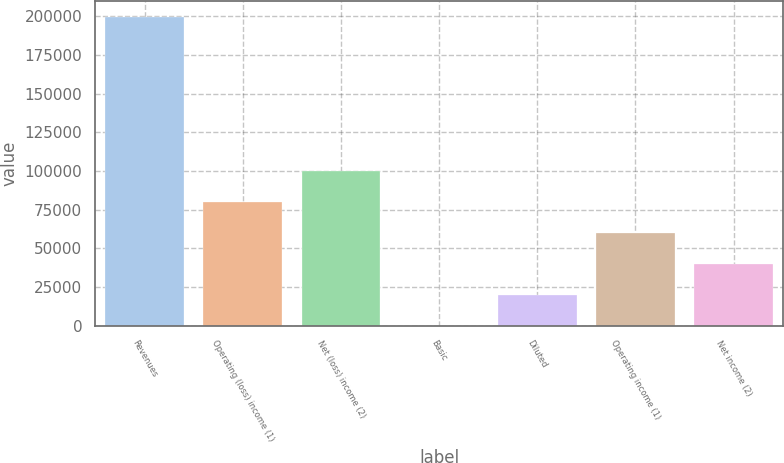<chart> <loc_0><loc_0><loc_500><loc_500><bar_chart><fcel>Revenues<fcel>Operating (loss) income (1)<fcel>Net (loss) income (2)<fcel>Basic<fcel>Diluted<fcel>Operating income (1)<fcel>Net income (2)<nl><fcel>199824<fcel>79929.7<fcel>99912.1<fcel>0.13<fcel>19982.5<fcel>59947.3<fcel>39964.9<nl></chart> 